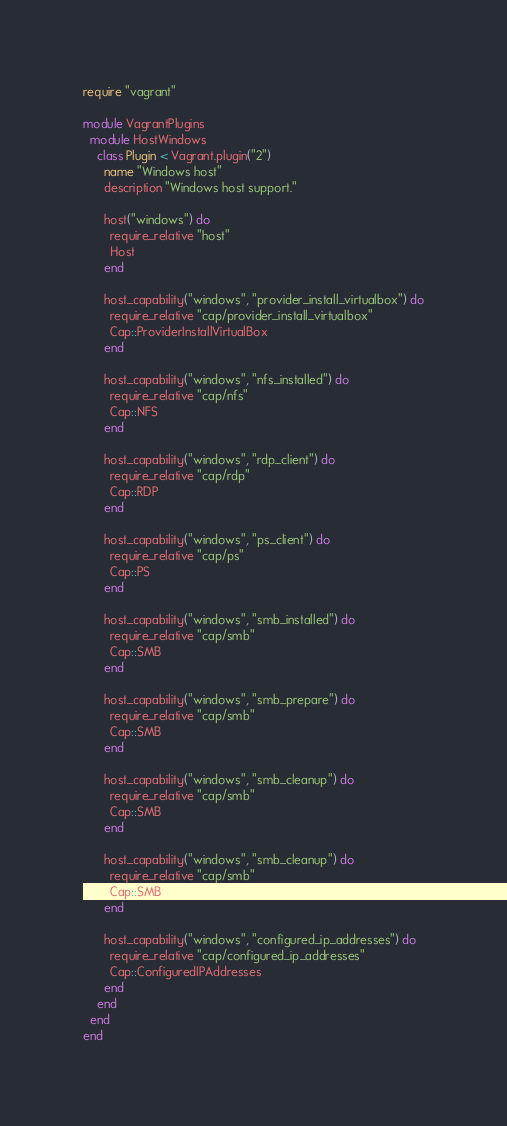Convert code to text. <code><loc_0><loc_0><loc_500><loc_500><_Ruby_>require "vagrant"

module VagrantPlugins
  module HostWindows
    class Plugin < Vagrant.plugin("2")
      name "Windows host"
      description "Windows host support."

      host("windows") do
        require_relative "host"
        Host
      end

      host_capability("windows", "provider_install_virtualbox") do
        require_relative "cap/provider_install_virtualbox"
        Cap::ProviderInstallVirtualBox
      end

      host_capability("windows", "nfs_installed") do
        require_relative "cap/nfs"
        Cap::NFS
      end

      host_capability("windows", "rdp_client") do
        require_relative "cap/rdp"
        Cap::RDP
      end

      host_capability("windows", "ps_client") do
        require_relative "cap/ps"
        Cap::PS
      end

      host_capability("windows", "smb_installed") do
        require_relative "cap/smb"
        Cap::SMB
      end

      host_capability("windows", "smb_prepare") do
        require_relative "cap/smb"
        Cap::SMB
      end

      host_capability("windows", "smb_cleanup") do
        require_relative "cap/smb"
        Cap::SMB
      end

      host_capability("windows", "smb_cleanup") do
        require_relative "cap/smb"
        Cap::SMB
      end

      host_capability("windows", "configured_ip_addresses") do
        require_relative "cap/configured_ip_addresses"
        Cap::ConfiguredIPAddresses
      end
    end
  end
end
</code> 